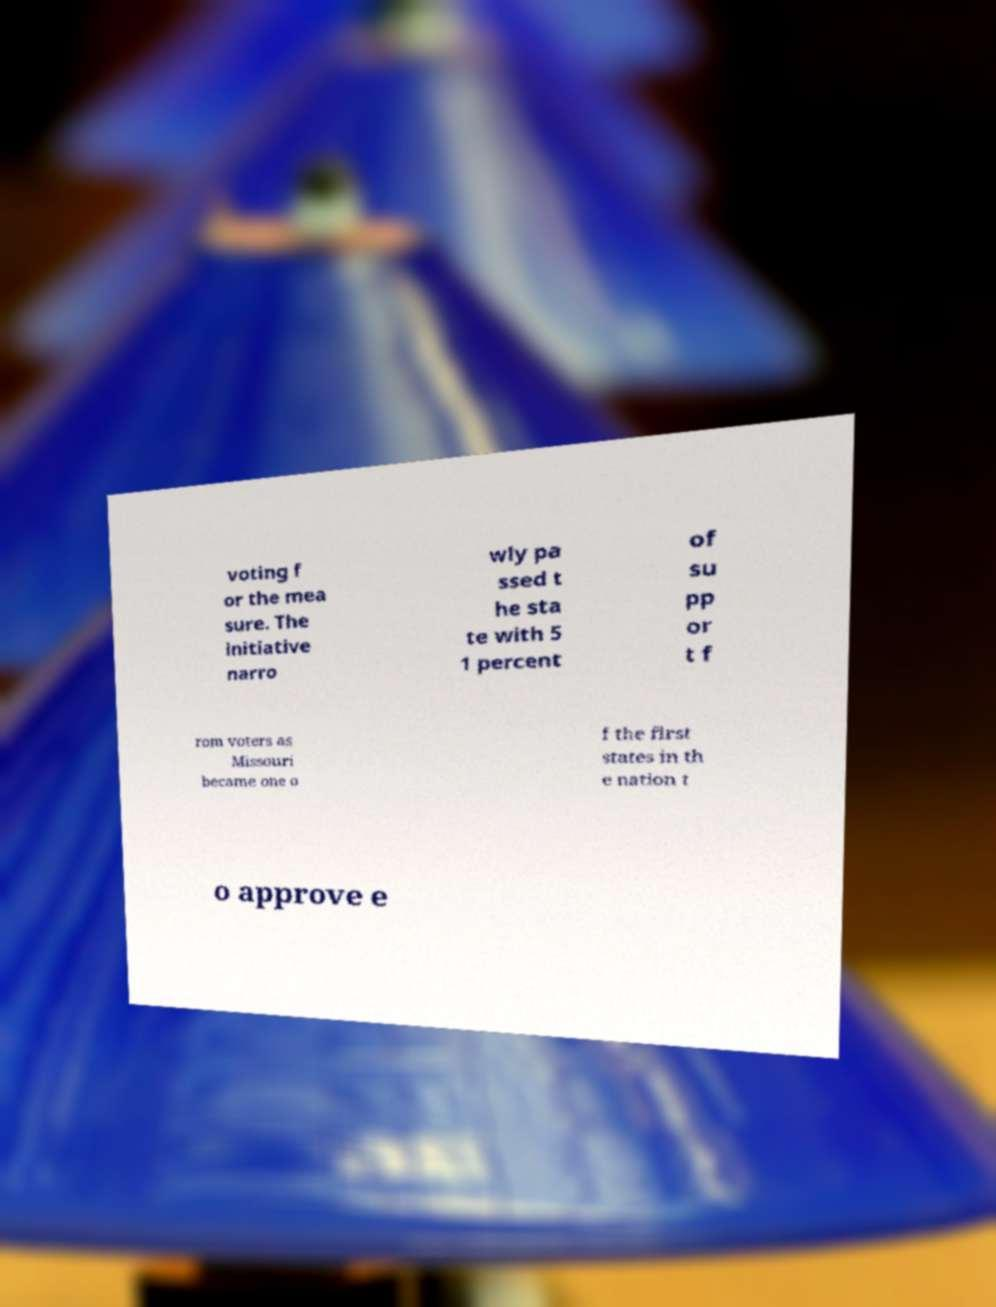I need the written content from this picture converted into text. Can you do that? voting f or the mea sure. The initiative narro wly pa ssed t he sta te with 5 1 percent of su pp or t f rom voters as Missouri became one o f the first states in th e nation t o approve e 